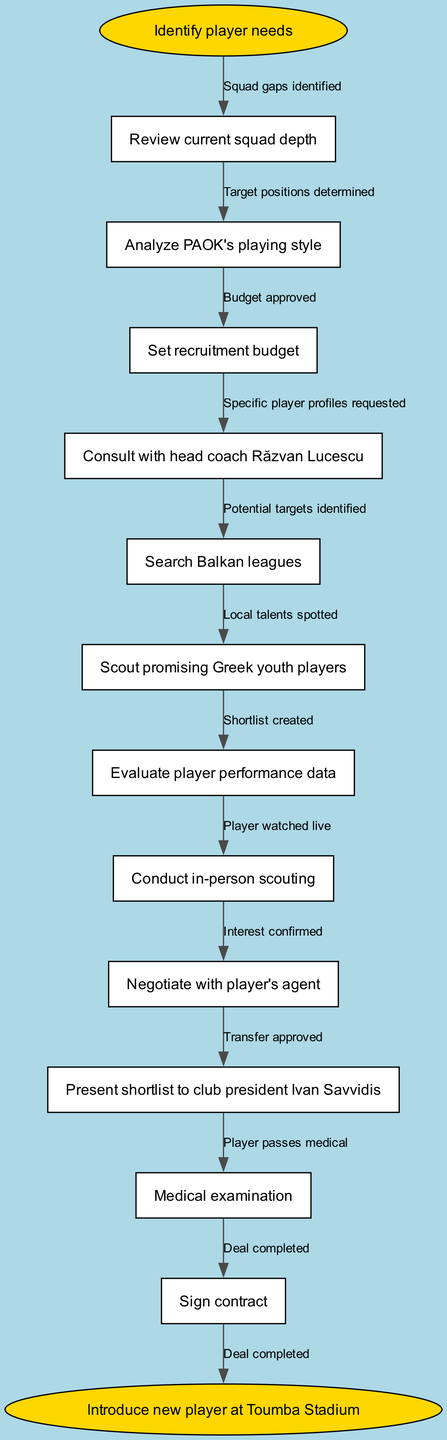What is the first step in the PAOK FC scouting workflow? The diagram indicates that the first step is "Identify player needs," which is represented at the start of the flow.
Answer: Identify player needs How many nodes are there in the diagram? By counting the nodes listed in the diagram, including the start and end, there are a total of 13 nodes.
Answer: 13 What action leads to "Set recruitment budget"? According to the flow, "Review current squad depth" is the action that leads to "Set recruitment budget."
Answer: Review current squad depth Which node appears directly after "Conduct in-person scouting"? The next node in the sequence after "Conduct in-person scouting" is "Negotiate with player's agent," as indicated by the directed edge.
Answer: Negotiate with player's agent What is the final outcome of the recruitment process? At the end of the flow diagram, the outcome is stated as "Introduce new player at Toumba Stadium," which signifies the conclusion of the recruitment process.
Answer: Introduce new player at Toumba Stadium How many edges connect the nodes in the diagram? The diagram includes a total of 12 edges since each node (except the last) connects to the next node, plus one edge from the last node to the end.
Answer: 12 Which action follows "Search Balkan leagues"? "Scout promising Greek youth players" directly follows "Search Balkan leagues" in the recruitment workflow, as indicated by the connection in the diagram.
Answer: Scout promising Greek youth players What is the relationship between "Evaluate player performance data" and "Shortlist created"? "Evaluate player performance data" leads to "Shortlist created," which confirms that the evaluation stage is critical for forming the shortlist of players.
Answer: Evaluate player performance data -> Shortlist created What process comes before “Transfer approved”? The process that comes immediately before “Transfer approved” is “Interest confirmed,” showing that confirming interest is essential for moving forward with a transfer.
Answer: Interest confirmed 